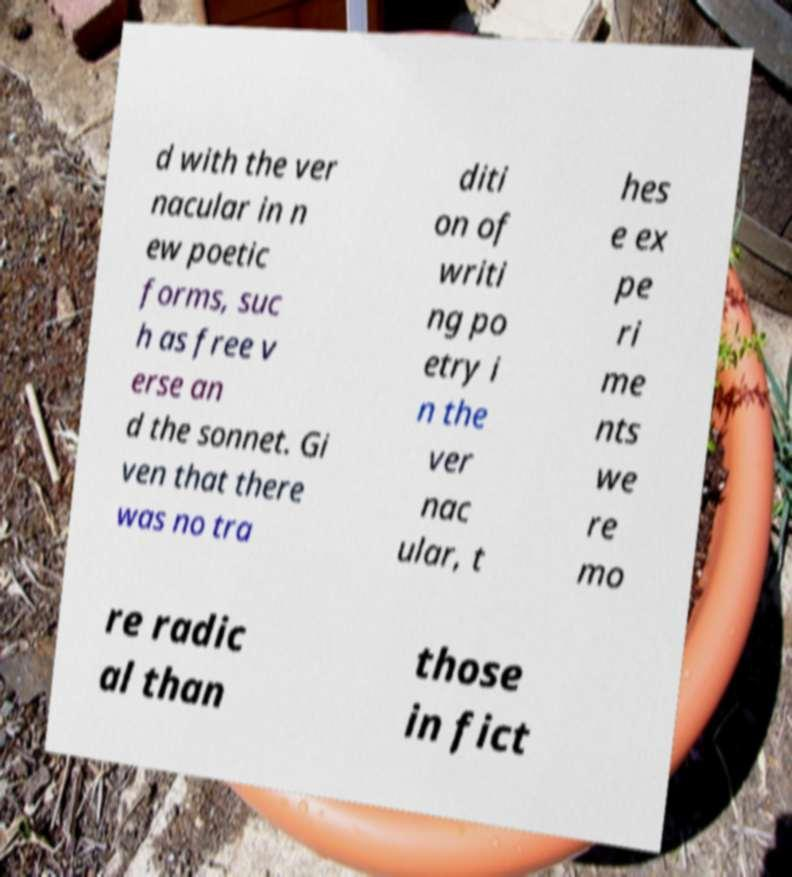Could you assist in decoding the text presented in this image and type it out clearly? d with the ver nacular in n ew poetic forms, suc h as free v erse an d the sonnet. Gi ven that there was no tra diti on of writi ng po etry i n the ver nac ular, t hes e ex pe ri me nts we re mo re radic al than those in fict 